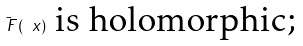<formula> <loc_0><loc_0><loc_500><loc_500>\bar { \ F } ( \ x ) \text { is holomorphic;}</formula> 